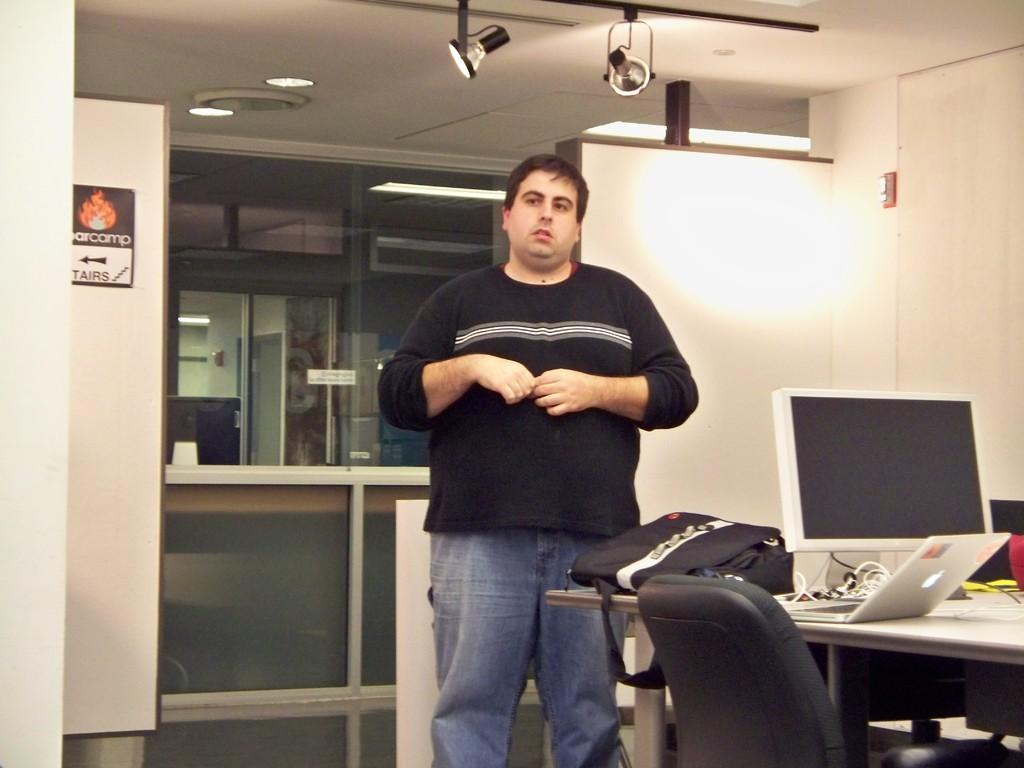What is the man doing in the image? The man is standing in the image. What object can be seen on the table in the image? There is a laptop and a system (possibly a computer) on the table in the image. What else is on the table in the image? A bag is also on the table in the image. What type of furniture is in the image? There is a chair in the image. What can be seen at the back side of the image? There is a glass door at the back side of the image. How much wine is being poured from the pan in the image? There is no wine or pan present in the image. 